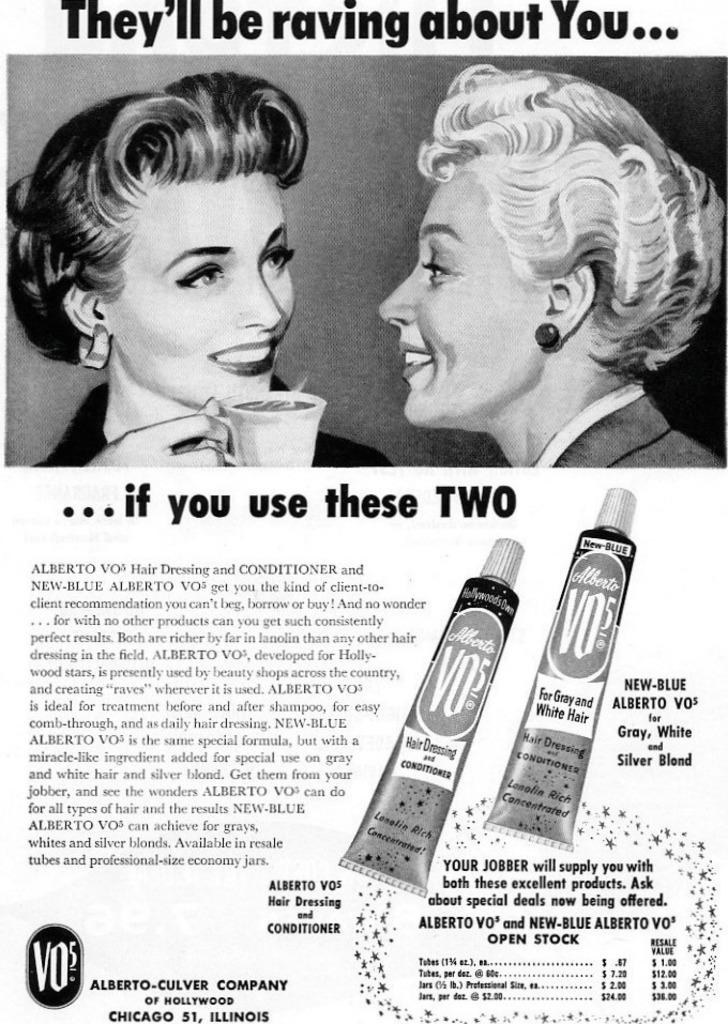How many people are in the image? There are two girls in the image. What are the girls holding in their hands? The girls are holding cups in their hands. What can be seen at the bottom of the image? There are two tubes at the bottom of the image. Where is the text located in the image? The text is on the left side of the image. What type of stocking is the girl wearing on her left leg in the image? There is no mention of stockings or any clothing in the provided facts, so we cannot determine what type of stocking the girl might be wearing. 